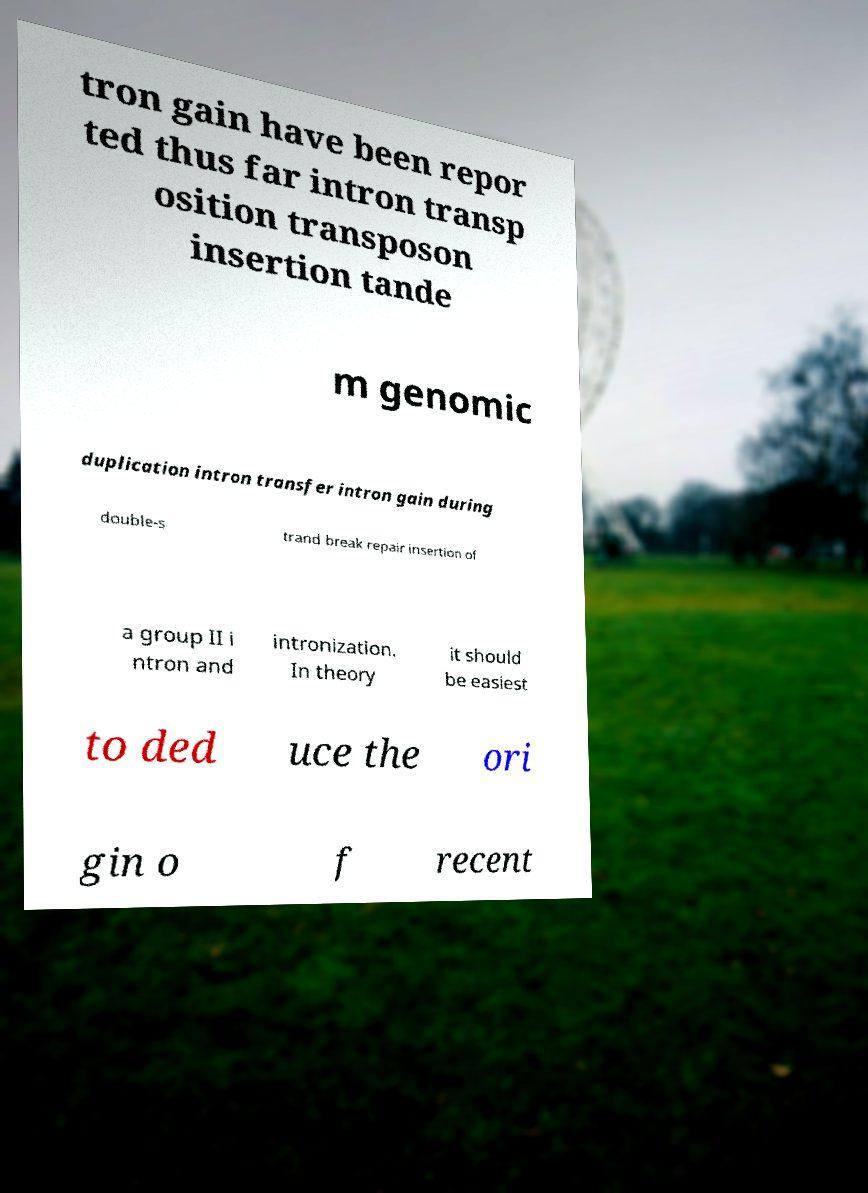Please read and relay the text visible in this image. What does it say? tron gain have been repor ted thus far intron transp osition transposon insertion tande m genomic duplication intron transfer intron gain during double-s trand break repair insertion of a group II i ntron and intronization. In theory it should be easiest to ded uce the ori gin o f recent 